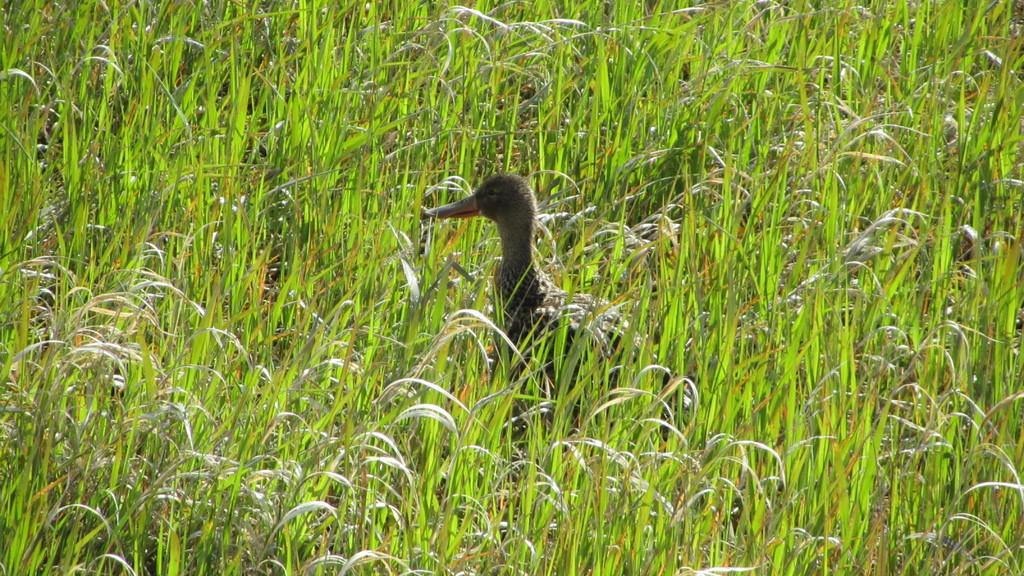What type of animal is present in the image? There is a duck in the image. What type of vegetation can be seen in the image? There is grass visible in the image. What type of cake is being served at the nighttime event in the image? There is no cake, nighttime event, or any reference to time of day in the image; it features a duck and grass. 